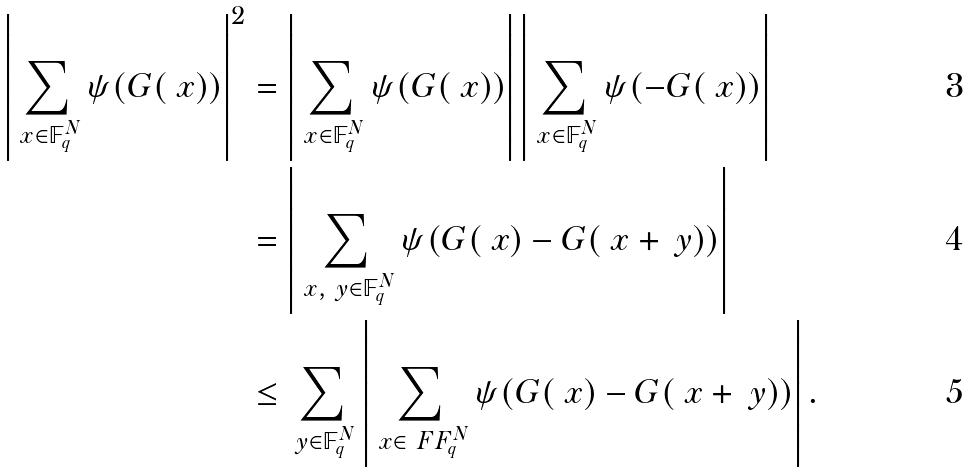<formula> <loc_0><loc_0><loc_500><loc_500>\left | \sum _ { \ x \in \mathbb { F } _ { q } ^ { N } } \psi ( G ( \ x ) ) \right | ^ { 2 } & = \left | \sum _ { \ x \in \mathbb { F } _ { q } ^ { N } } \psi ( G ( \ x ) ) \right | \left | \sum _ { \ x \in \mathbb { F } _ { q } ^ { N } } \psi ( - G ( \ x ) ) \right | \\ & = \left | \sum _ { \ x , \ y \in \mathbb { F } _ { q } ^ { N } } \psi ( G ( \ x ) - G ( \ x + \ y ) ) \right | \\ & \leq \sum _ { \ y \in \mathbb { F } _ { q } ^ { N } } \left | \sum _ { \ x \in \ F F _ { q } ^ { N } } \psi ( G ( \ x ) - G ( \ x + \ y ) ) \right | .</formula> 